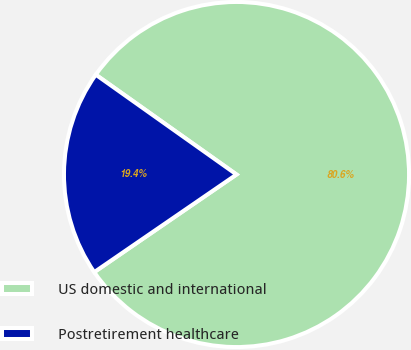Convert chart. <chart><loc_0><loc_0><loc_500><loc_500><pie_chart><fcel>US domestic and international<fcel>Postretirement healthcare<nl><fcel>80.61%<fcel>19.39%<nl></chart> 